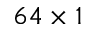Convert formula to latex. <formula><loc_0><loc_0><loc_500><loc_500>6 4 \times 1</formula> 